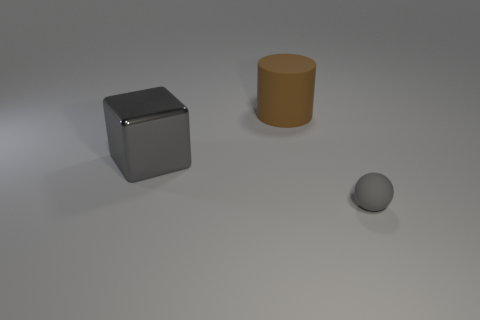How many other things are there of the same size as the gray metallic block?
Ensure brevity in your answer.  1. The ball that is made of the same material as the brown thing is what color?
Give a very brief answer. Gray. There is a matte thing left of the tiny object that is in front of the gray shiny object; are there any matte cylinders that are to the left of it?
Ensure brevity in your answer.  No. What is the shape of the large brown object?
Offer a terse response. Cylinder. Are there fewer gray metallic blocks in front of the big metallic object than large cyan matte objects?
Your response must be concise. No. Are there any other gray things that have the same shape as the small gray rubber object?
Your answer should be compact. No. There is a brown thing that is the same size as the gray block; what is its shape?
Ensure brevity in your answer.  Cylinder. How many objects are either large rubber objects or big shiny things?
Offer a very short reply. 2. Are there any tiny gray matte balls?
Your answer should be very brief. Yes. Is the number of large green matte balls less than the number of gray rubber balls?
Your answer should be very brief. Yes. 